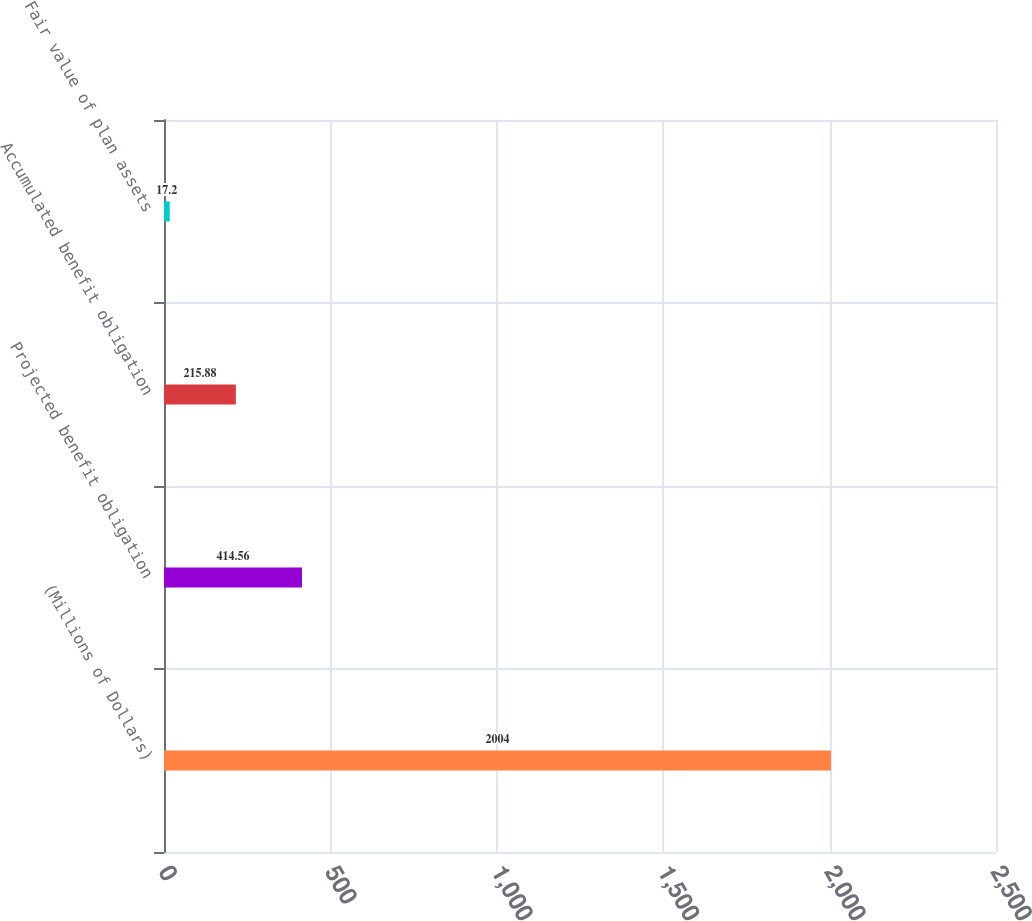<chart> <loc_0><loc_0><loc_500><loc_500><bar_chart><fcel>(Millions of Dollars)<fcel>Projected benefit obligation<fcel>Accumulated benefit obligation<fcel>Fair value of plan assets<nl><fcel>2004<fcel>414.56<fcel>215.88<fcel>17.2<nl></chart> 